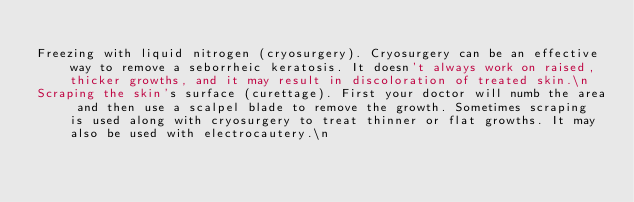<code> <loc_0><loc_0><loc_500><loc_500><_YAML_>
Freezing with liquid nitrogen (cryosurgery). Cryosurgery can be an effective way to remove a seborrheic keratosis. It doesn't always work on raised, thicker growths, and it may result in discoloration of treated skin.\n
Scraping the skin's surface (curettage). First your doctor will numb the area and then use a scalpel blade to remove the growth. Sometimes scraping is used along with cryosurgery to treat thinner or flat growths. It may also be used with electrocautery.\n</code> 